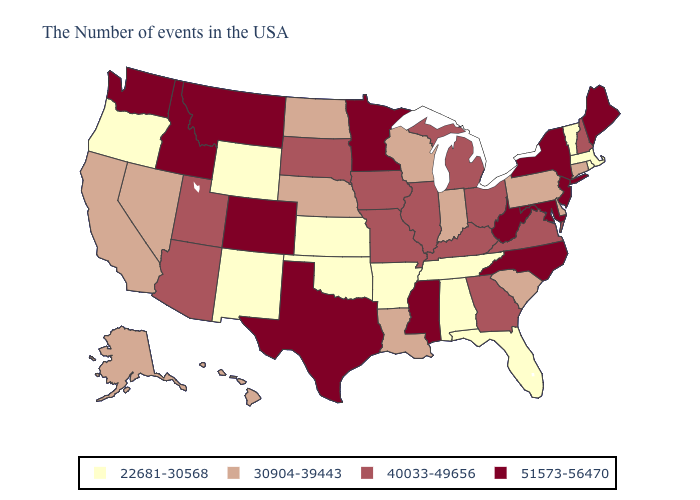Among the states that border Michigan , does Ohio have the lowest value?
Answer briefly. No. What is the value of Indiana?
Be succinct. 30904-39443. Which states have the highest value in the USA?
Concise answer only. Maine, New York, New Jersey, Maryland, North Carolina, West Virginia, Mississippi, Minnesota, Texas, Colorado, Montana, Idaho, Washington. What is the lowest value in the Northeast?
Keep it brief. 22681-30568. What is the highest value in the West ?
Give a very brief answer. 51573-56470. Does New Jersey have the same value as Massachusetts?
Give a very brief answer. No. Name the states that have a value in the range 40033-49656?
Short answer required. New Hampshire, Virginia, Ohio, Georgia, Michigan, Kentucky, Illinois, Missouri, Iowa, South Dakota, Utah, Arizona. Is the legend a continuous bar?
Quick response, please. No. What is the value of Maryland?
Short answer required. 51573-56470. Name the states that have a value in the range 51573-56470?
Quick response, please. Maine, New York, New Jersey, Maryland, North Carolina, West Virginia, Mississippi, Minnesota, Texas, Colorado, Montana, Idaho, Washington. Does Kentucky have the highest value in the South?
Concise answer only. No. Does Alaska have a higher value than Indiana?
Be succinct. No. Does the map have missing data?
Be succinct. No. Name the states that have a value in the range 40033-49656?
Short answer required. New Hampshire, Virginia, Ohio, Georgia, Michigan, Kentucky, Illinois, Missouri, Iowa, South Dakota, Utah, Arizona. Name the states that have a value in the range 51573-56470?
Quick response, please. Maine, New York, New Jersey, Maryland, North Carolina, West Virginia, Mississippi, Minnesota, Texas, Colorado, Montana, Idaho, Washington. 